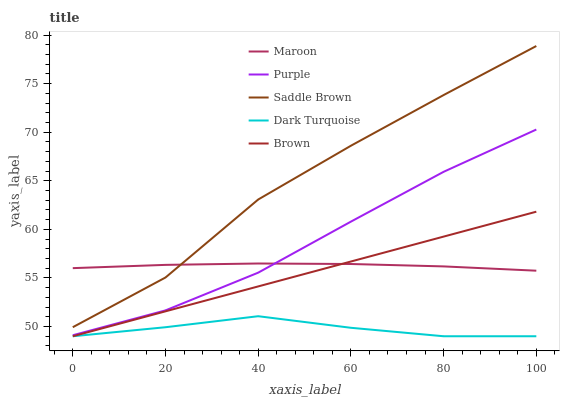Does Saddle Brown have the minimum area under the curve?
Answer yes or no. No. Does Dark Turquoise have the maximum area under the curve?
Answer yes or no. No. Is Dark Turquoise the smoothest?
Answer yes or no. No. Is Dark Turquoise the roughest?
Answer yes or no. No. Does Saddle Brown have the lowest value?
Answer yes or no. No. Does Dark Turquoise have the highest value?
Answer yes or no. No. Is Dark Turquoise less than Maroon?
Answer yes or no. Yes. Is Maroon greater than Dark Turquoise?
Answer yes or no. Yes. Does Dark Turquoise intersect Maroon?
Answer yes or no. No. 